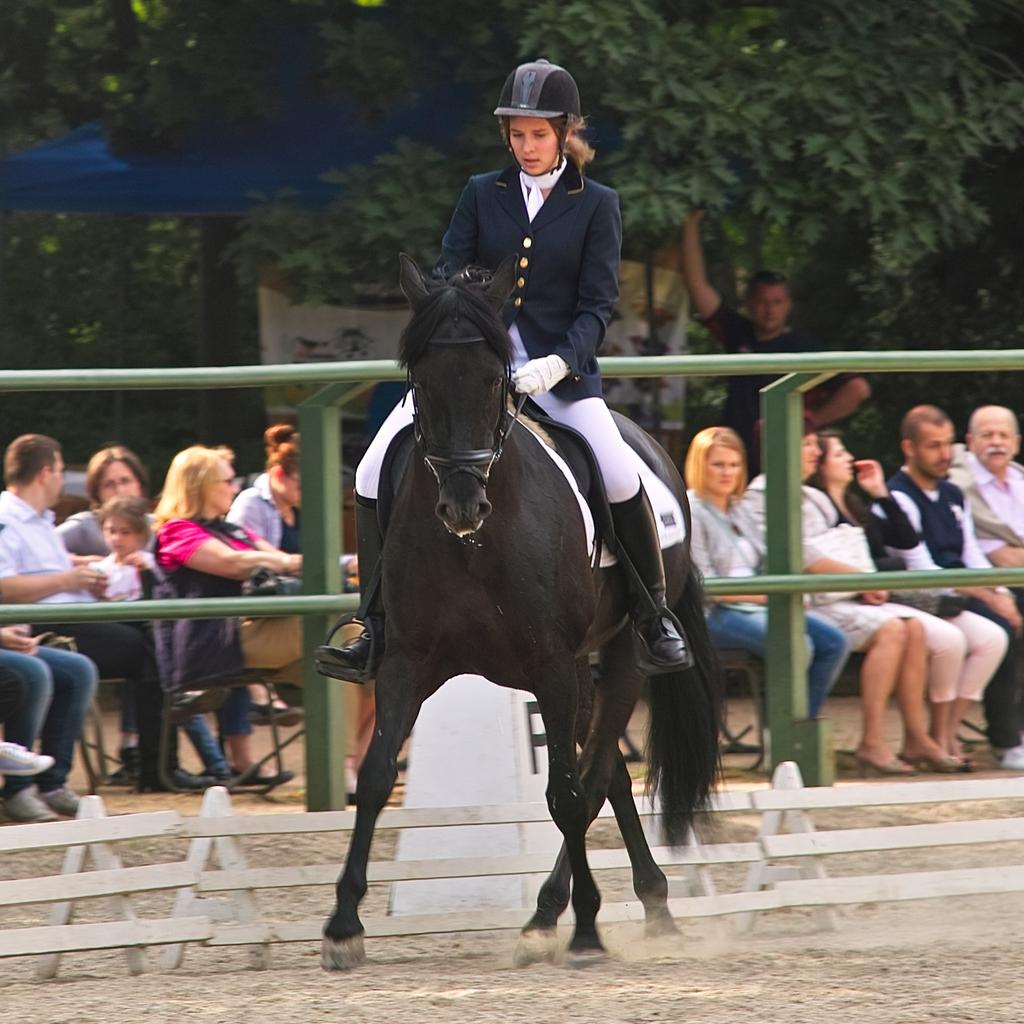What is the woman in the image doing? The woman is sitting on a horse in the image. What can be seen in the background of the image? There is a railing, people sitting, a tree, and a wall in the background of the image. What type of patch is the woman sewing onto the horse's saddle in the image? There is no patch or sewing activity present in the image. 